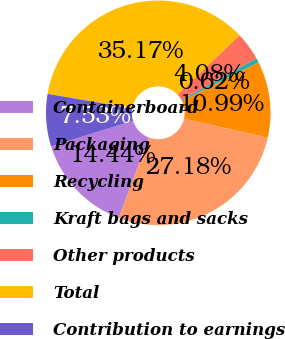Convert chart. <chart><loc_0><loc_0><loc_500><loc_500><pie_chart><fcel>Containerboard<fcel>Packaging<fcel>Recycling<fcel>Kraft bags and sacks<fcel>Other products<fcel>Total<fcel>Contribution to earnings<nl><fcel>14.44%<fcel>27.18%<fcel>10.99%<fcel>0.62%<fcel>4.08%<fcel>35.17%<fcel>7.53%<nl></chart> 